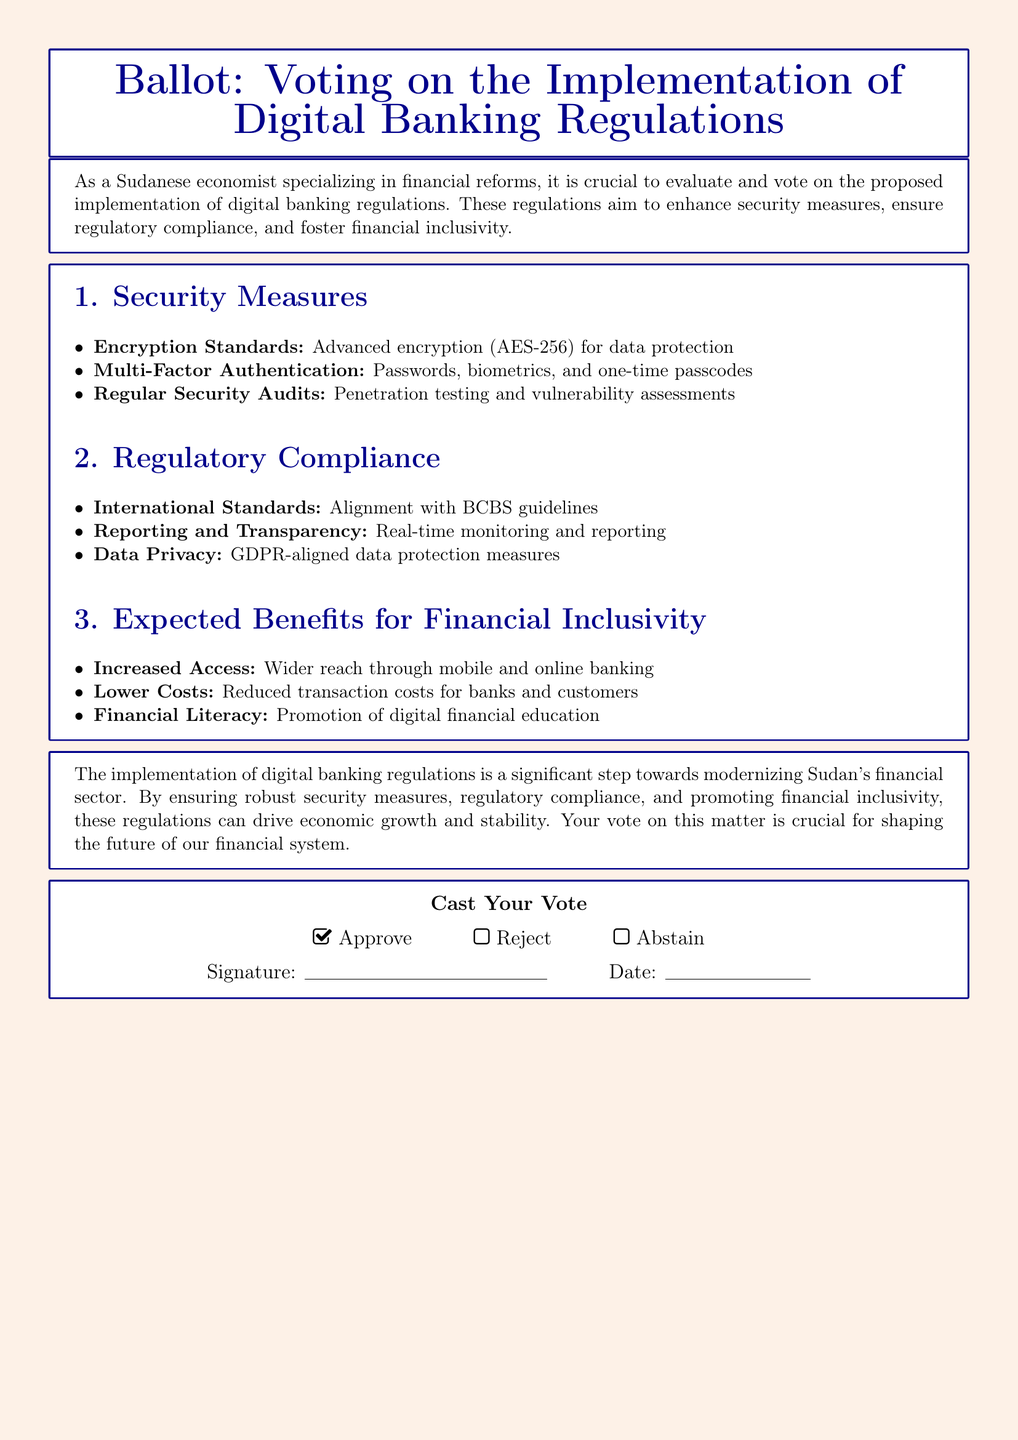What encryption standard is mentioned? The document states that AES-256 is the encryption standard for data protection.
Answer: AES-256 What are the authentication methods listed? The document lists passwords, biometrics, and one-time passcodes as authentication methods.
Answer: Passwords, biometrics, one-time passcodes What is the first expected benefit for financial inclusivity? The first expected benefit mentioned in the document is wider reach through mobile and online banking.
Answer: Increased Access Which international standards does the regulation align with? The document states that the regulations align with BCBS guidelines for international standards.
Answer: BCBS guidelines What type of education is promoted by the expected benefits? The expected benefits include the promotion of digital financial education.
Answer: Digital financial education How many options are provided for voting? The document provides three options for voting: Approve, Reject, and Abstain.
Answer: Three options What is the purpose of the regular security audits? The regular security audits aim for penetration testing and vulnerability assessments.
Answer: Penetration testing and vulnerability assessments What color is the background of the ballot? The background color of the ballot is a light sand color.
Answer: Light sand color 